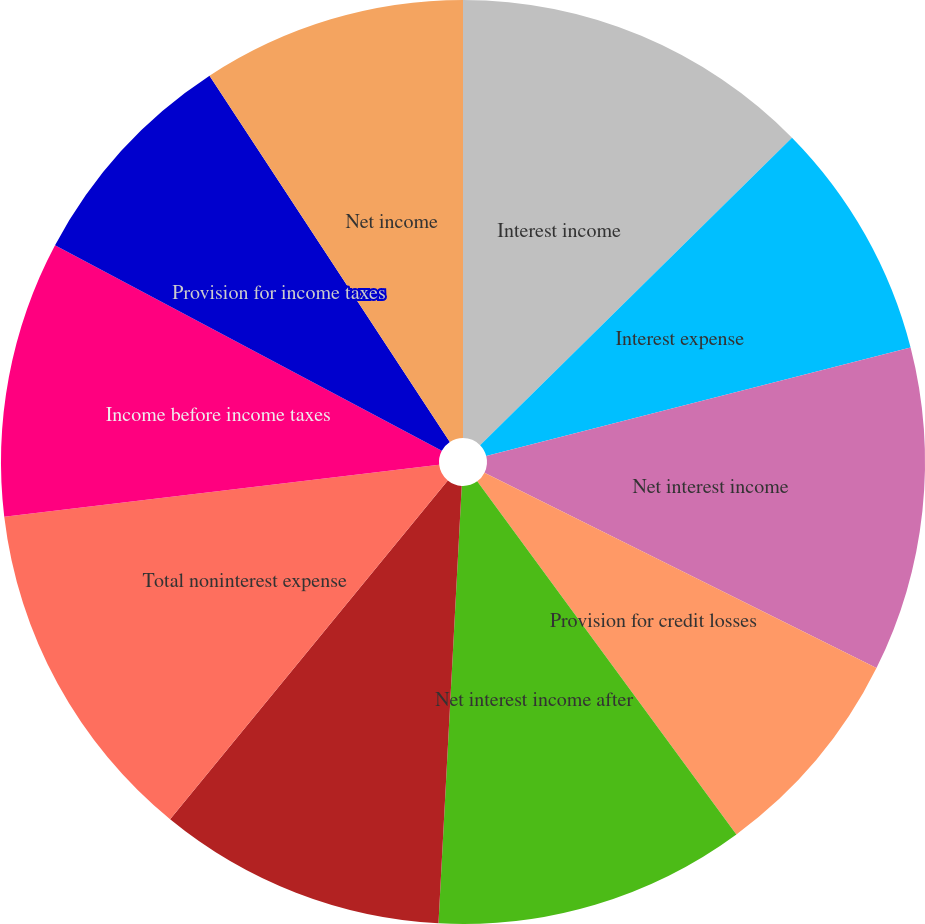Convert chart. <chart><loc_0><loc_0><loc_500><loc_500><pie_chart><fcel>Interest income<fcel>Interest expense<fcel>Net interest income<fcel>Provision for credit losses<fcel>Net interest income after<fcel>Total noninterest income<fcel>Total noninterest expense<fcel>Income before income taxes<fcel>Provision for income taxes<fcel>Net income<nl><fcel>12.61%<fcel>8.4%<fcel>11.34%<fcel>7.56%<fcel>10.92%<fcel>10.08%<fcel>12.18%<fcel>9.66%<fcel>7.98%<fcel>9.24%<nl></chart> 